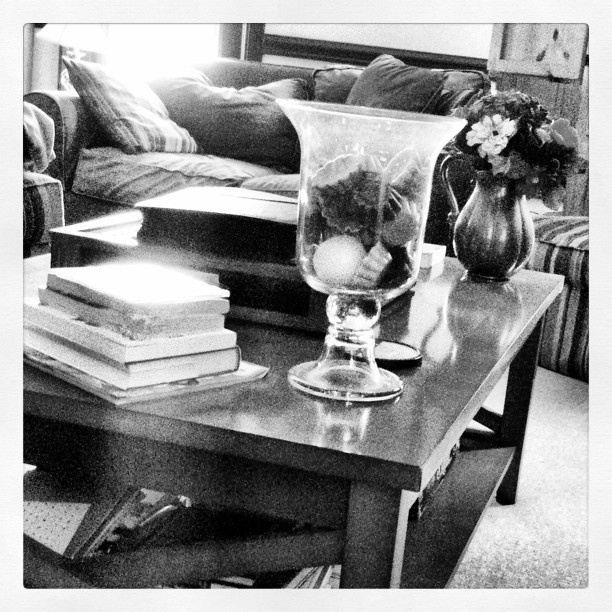Describe the objects in this image and their specific colors. I can see couch in whitesmoke, gray, lightgray, darkgray, and black tones, vase in whitesmoke, lightgray, darkgray, gray, and black tones, book in whitesmoke, black, white, gray, and darkgray tones, book in whitesmoke, black, white, gray, and darkgray tones, and vase in whitesmoke, black, gray, darkgray, and gainsboro tones in this image. 